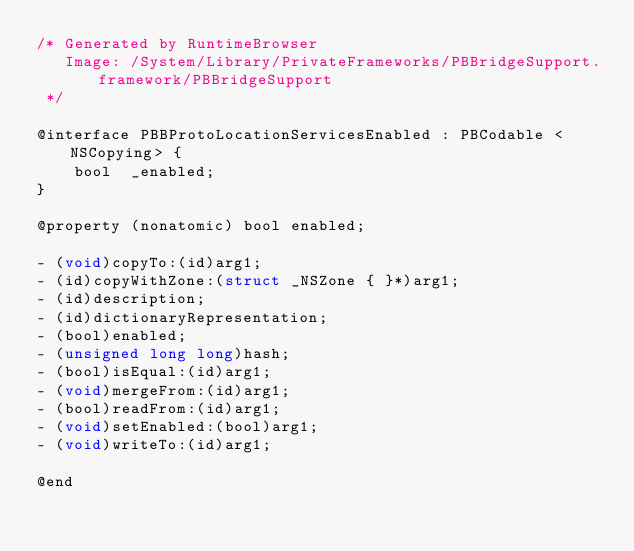<code> <loc_0><loc_0><loc_500><loc_500><_C_>/* Generated by RuntimeBrowser
   Image: /System/Library/PrivateFrameworks/PBBridgeSupport.framework/PBBridgeSupport
 */

@interface PBBProtoLocationServicesEnabled : PBCodable <NSCopying> {
    bool  _enabled;
}

@property (nonatomic) bool enabled;

- (void)copyTo:(id)arg1;
- (id)copyWithZone:(struct _NSZone { }*)arg1;
- (id)description;
- (id)dictionaryRepresentation;
- (bool)enabled;
- (unsigned long long)hash;
- (bool)isEqual:(id)arg1;
- (void)mergeFrom:(id)arg1;
- (bool)readFrom:(id)arg1;
- (void)setEnabled:(bool)arg1;
- (void)writeTo:(id)arg1;

@end
</code> 